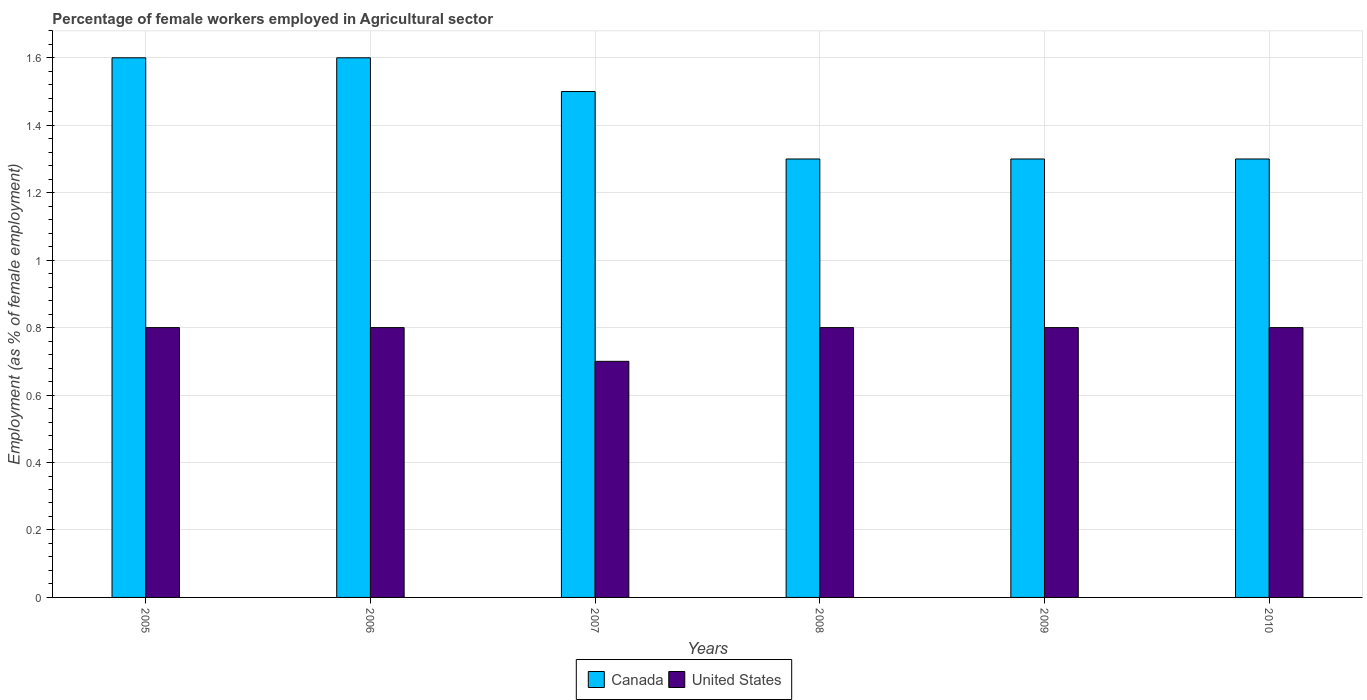How many different coloured bars are there?
Provide a succinct answer. 2. Are the number of bars per tick equal to the number of legend labels?
Give a very brief answer. Yes. How many bars are there on the 3rd tick from the left?
Provide a short and direct response. 2. In how many cases, is the number of bars for a given year not equal to the number of legend labels?
Your response must be concise. 0. What is the percentage of females employed in Agricultural sector in Canada in 2009?
Your response must be concise. 1.3. Across all years, what is the maximum percentage of females employed in Agricultural sector in United States?
Your answer should be compact. 0.8. Across all years, what is the minimum percentage of females employed in Agricultural sector in United States?
Provide a succinct answer. 0.7. In which year was the percentage of females employed in Agricultural sector in United States maximum?
Offer a terse response. 2005. What is the total percentage of females employed in Agricultural sector in Canada in the graph?
Make the answer very short. 8.6. What is the difference between the percentage of females employed in Agricultural sector in United States in 2008 and that in 2010?
Ensure brevity in your answer.  0. What is the difference between the percentage of females employed in Agricultural sector in United States in 2008 and the percentage of females employed in Agricultural sector in Canada in 2006?
Offer a terse response. -0.8. What is the average percentage of females employed in Agricultural sector in Canada per year?
Provide a succinct answer. 1.43. In the year 2010, what is the difference between the percentage of females employed in Agricultural sector in United States and percentage of females employed in Agricultural sector in Canada?
Your response must be concise. -0.5. In how many years, is the percentage of females employed in Agricultural sector in Canada greater than 0.68 %?
Your response must be concise. 6. What is the ratio of the percentage of females employed in Agricultural sector in Canada in 2006 to that in 2008?
Your answer should be compact. 1.23. Is the difference between the percentage of females employed in Agricultural sector in United States in 2006 and 2010 greater than the difference between the percentage of females employed in Agricultural sector in Canada in 2006 and 2010?
Provide a short and direct response. No. What is the difference between the highest and the lowest percentage of females employed in Agricultural sector in United States?
Provide a short and direct response. 0.1. Is the sum of the percentage of females employed in Agricultural sector in United States in 2005 and 2006 greater than the maximum percentage of females employed in Agricultural sector in Canada across all years?
Make the answer very short. No. What does the 2nd bar from the left in 2007 represents?
Provide a short and direct response. United States. How many bars are there?
Offer a terse response. 12. Are all the bars in the graph horizontal?
Offer a terse response. No. Does the graph contain any zero values?
Offer a terse response. No. Where does the legend appear in the graph?
Give a very brief answer. Bottom center. How many legend labels are there?
Your response must be concise. 2. What is the title of the graph?
Keep it short and to the point. Percentage of female workers employed in Agricultural sector. What is the label or title of the Y-axis?
Give a very brief answer. Employment (as % of female employment). What is the Employment (as % of female employment) of Canada in 2005?
Your answer should be very brief. 1.6. What is the Employment (as % of female employment) of United States in 2005?
Offer a terse response. 0.8. What is the Employment (as % of female employment) of Canada in 2006?
Make the answer very short. 1.6. What is the Employment (as % of female employment) in United States in 2006?
Provide a short and direct response. 0.8. What is the Employment (as % of female employment) in Canada in 2007?
Give a very brief answer. 1.5. What is the Employment (as % of female employment) of United States in 2007?
Provide a succinct answer. 0.7. What is the Employment (as % of female employment) of Canada in 2008?
Your answer should be very brief. 1.3. What is the Employment (as % of female employment) of United States in 2008?
Ensure brevity in your answer.  0.8. What is the Employment (as % of female employment) of Canada in 2009?
Offer a terse response. 1.3. What is the Employment (as % of female employment) in United States in 2009?
Provide a short and direct response. 0.8. What is the Employment (as % of female employment) in Canada in 2010?
Make the answer very short. 1.3. What is the Employment (as % of female employment) of United States in 2010?
Offer a terse response. 0.8. Across all years, what is the maximum Employment (as % of female employment) of Canada?
Your answer should be very brief. 1.6. Across all years, what is the maximum Employment (as % of female employment) in United States?
Give a very brief answer. 0.8. Across all years, what is the minimum Employment (as % of female employment) in Canada?
Your response must be concise. 1.3. Across all years, what is the minimum Employment (as % of female employment) of United States?
Provide a succinct answer. 0.7. What is the total Employment (as % of female employment) of Canada in the graph?
Offer a terse response. 8.6. What is the total Employment (as % of female employment) of United States in the graph?
Give a very brief answer. 4.7. What is the difference between the Employment (as % of female employment) in United States in 2005 and that in 2006?
Ensure brevity in your answer.  0. What is the difference between the Employment (as % of female employment) of Canada in 2005 and that in 2008?
Your answer should be very brief. 0.3. What is the difference between the Employment (as % of female employment) of United States in 2005 and that in 2008?
Ensure brevity in your answer.  0. What is the difference between the Employment (as % of female employment) of Canada in 2005 and that in 2010?
Offer a terse response. 0.3. What is the difference between the Employment (as % of female employment) of Canada in 2006 and that in 2007?
Provide a succinct answer. 0.1. What is the difference between the Employment (as % of female employment) in United States in 2006 and that in 2007?
Make the answer very short. 0.1. What is the difference between the Employment (as % of female employment) of United States in 2006 and that in 2008?
Keep it short and to the point. 0. What is the difference between the Employment (as % of female employment) in United States in 2006 and that in 2010?
Offer a very short reply. 0. What is the difference between the Employment (as % of female employment) of Canada in 2007 and that in 2008?
Your response must be concise. 0.2. What is the difference between the Employment (as % of female employment) of Canada in 2008 and that in 2009?
Your answer should be very brief. 0. What is the difference between the Employment (as % of female employment) in United States in 2008 and that in 2010?
Ensure brevity in your answer.  0. What is the difference between the Employment (as % of female employment) in Canada in 2005 and the Employment (as % of female employment) in United States in 2008?
Make the answer very short. 0.8. What is the difference between the Employment (as % of female employment) of Canada in 2005 and the Employment (as % of female employment) of United States in 2009?
Give a very brief answer. 0.8. What is the difference between the Employment (as % of female employment) in Canada in 2006 and the Employment (as % of female employment) in United States in 2007?
Your answer should be compact. 0.9. What is the difference between the Employment (as % of female employment) of Canada in 2007 and the Employment (as % of female employment) of United States in 2008?
Offer a terse response. 0.7. What is the difference between the Employment (as % of female employment) of Canada in 2007 and the Employment (as % of female employment) of United States in 2010?
Offer a terse response. 0.7. What is the difference between the Employment (as % of female employment) of Canada in 2008 and the Employment (as % of female employment) of United States in 2010?
Provide a succinct answer. 0.5. What is the average Employment (as % of female employment) of Canada per year?
Ensure brevity in your answer.  1.43. What is the average Employment (as % of female employment) of United States per year?
Your answer should be compact. 0.78. In the year 2005, what is the difference between the Employment (as % of female employment) of Canada and Employment (as % of female employment) of United States?
Ensure brevity in your answer.  0.8. In the year 2006, what is the difference between the Employment (as % of female employment) of Canada and Employment (as % of female employment) of United States?
Ensure brevity in your answer.  0.8. In the year 2007, what is the difference between the Employment (as % of female employment) in Canada and Employment (as % of female employment) in United States?
Your answer should be very brief. 0.8. What is the ratio of the Employment (as % of female employment) in United States in 2005 to that in 2006?
Ensure brevity in your answer.  1. What is the ratio of the Employment (as % of female employment) in Canada in 2005 to that in 2007?
Keep it short and to the point. 1.07. What is the ratio of the Employment (as % of female employment) of Canada in 2005 to that in 2008?
Your answer should be very brief. 1.23. What is the ratio of the Employment (as % of female employment) in Canada in 2005 to that in 2009?
Your answer should be compact. 1.23. What is the ratio of the Employment (as % of female employment) of United States in 2005 to that in 2009?
Ensure brevity in your answer.  1. What is the ratio of the Employment (as % of female employment) of Canada in 2005 to that in 2010?
Make the answer very short. 1.23. What is the ratio of the Employment (as % of female employment) of United States in 2005 to that in 2010?
Offer a terse response. 1. What is the ratio of the Employment (as % of female employment) in Canada in 2006 to that in 2007?
Your response must be concise. 1.07. What is the ratio of the Employment (as % of female employment) of Canada in 2006 to that in 2008?
Offer a very short reply. 1.23. What is the ratio of the Employment (as % of female employment) of Canada in 2006 to that in 2009?
Offer a very short reply. 1.23. What is the ratio of the Employment (as % of female employment) of United States in 2006 to that in 2009?
Give a very brief answer. 1. What is the ratio of the Employment (as % of female employment) in Canada in 2006 to that in 2010?
Your answer should be very brief. 1.23. What is the ratio of the Employment (as % of female employment) of Canada in 2007 to that in 2008?
Provide a short and direct response. 1.15. What is the ratio of the Employment (as % of female employment) in Canada in 2007 to that in 2009?
Keep it short and to the point. 1.15. What is the ratio of the Employment (as % of female employment) of Canada in 2007 to that in 2010?
Your answer should be very brief. 1.15. What is the ratio of the Employment (as % of female employment) of Canada in 2008 to that in 2010?
Your answer should be compact. 1. What is the ratio of the Employment (as % of female employment) of United States in 2008 to that in 2010?
Your response must be concise. 1. What is the ratio of the Employment (as % of female employment) in United States in 2009 to that in 2010?
Make the answer very short. 1. What is the difference between the highest and the lowest Employment (as % of female employment) in Canada?
Make the answer very short. 0.3. 